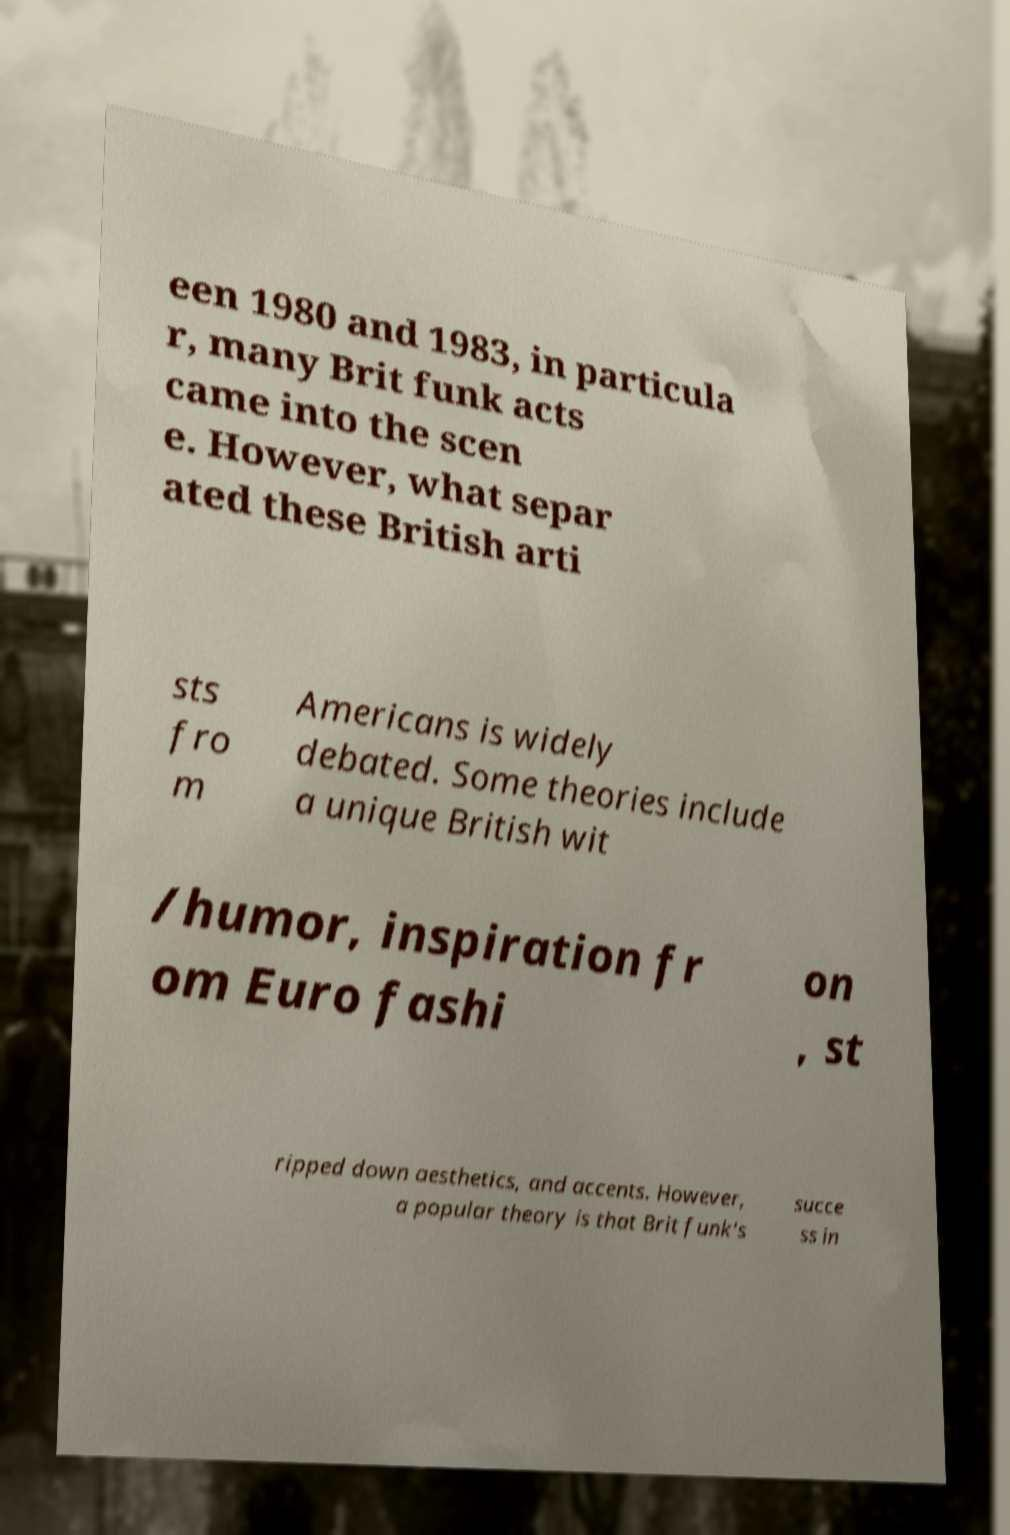What messages or text are displayed in this image? I need them in a readable, typed format. een 1980 and 1983, in particula r, many Brit funk acts came into the scen e. However, what separ ated these British arti sts fro m Americans is widely debated. Some theories include a unique British wit /humor, inspiration fr om Euro fashi on , st ripped down aesthetics, and accents. However, a popular theory is that Brit funk's succe ss in 